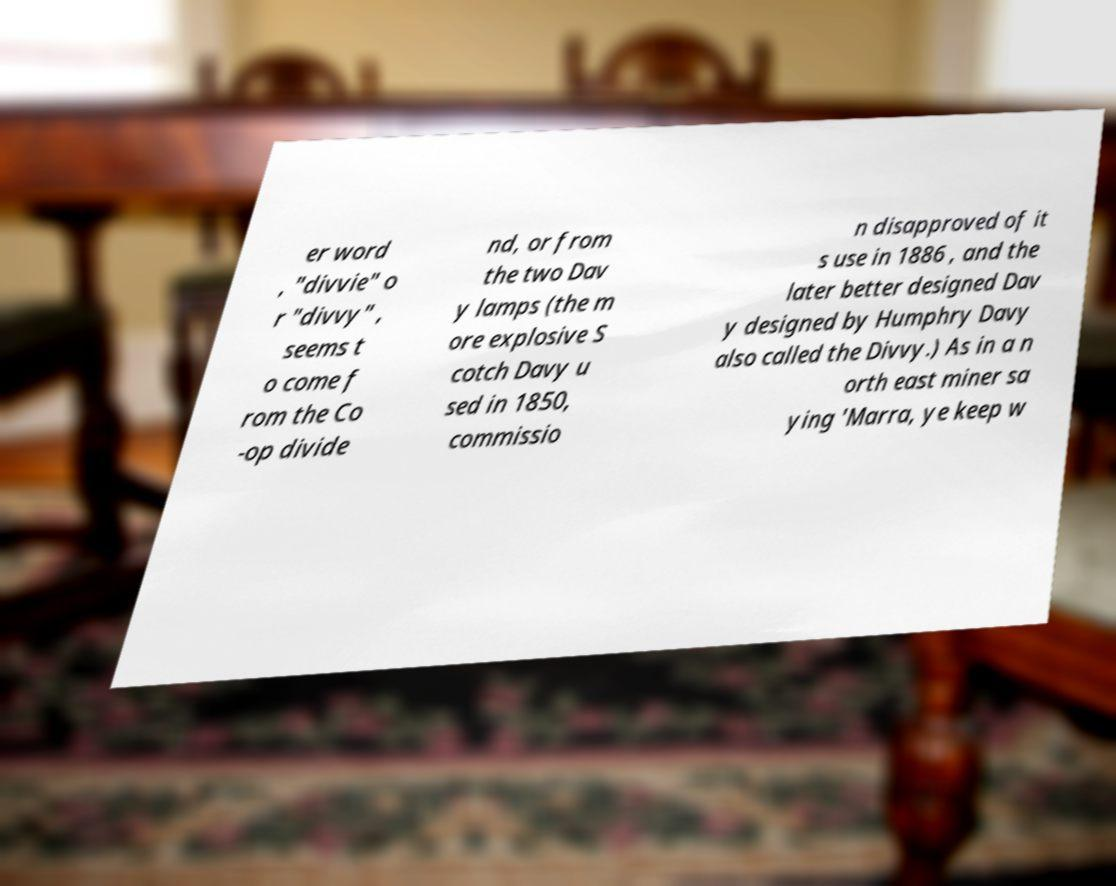Please read and relay the text visible in this image. What does it say? er word , "divvie" o r "divvy" , seems t o come f rom the Co -op divide nd, or from the two Dav y lamps (the m ore explosive S cotch Davy u sed in 1850, commissio n disapproved of it s use in 1886 , and the later better designed Dav y designed by Humphry Davy also called the Divvy.) As in a n orth east miner sa ying 'Marra, ye keep w 